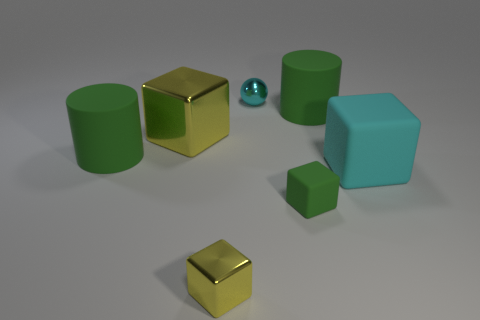Subtract all large shiny cubes. How many cubes are left? 3 Add 1 purple matte spheres. How many objects exist? 8 Subtract 1 cylinders. How many cylinders are left? 1 Subtract all green cubes. How many cubes are left? 3 Subtract all cylinders. How many objects are left? 5 Subtract all green blocks. How many brown spheres are left? 0 Add 6 small green rubber cubes. How many small green rubber cubes are left? 7 Add 3 large red objects. How many large red objects exist? 3 Subtract 0 gray cubes. How many objects are left? 7 Subtract all purple cylinders. Subtract all yellow balls. How many cylinders are left? 2 